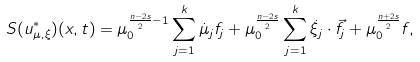<formula> <loc_0><loc_0><loc_500><loc_500>S ( u ^ { * } _ { \mu , \xi } ) ( x , t ) = \mu _ { 0 } ^ { \frac { n - 2 s } { 2 } - 1 } \sum _ { j = 1 } ^ { k } \dot { \mu } _ { j } f _ { j } + \mu _ { 0 } ^ { \frac { n - 2 s } { 2 } } \sum _ { j = 1 } ^ { k } \dot { \xi } _ { j } \cdot \vec { f } _ { j } + \mu _ { 0 } ^ { \frac { n + 2 s } { 2 } } f ,</formula> 